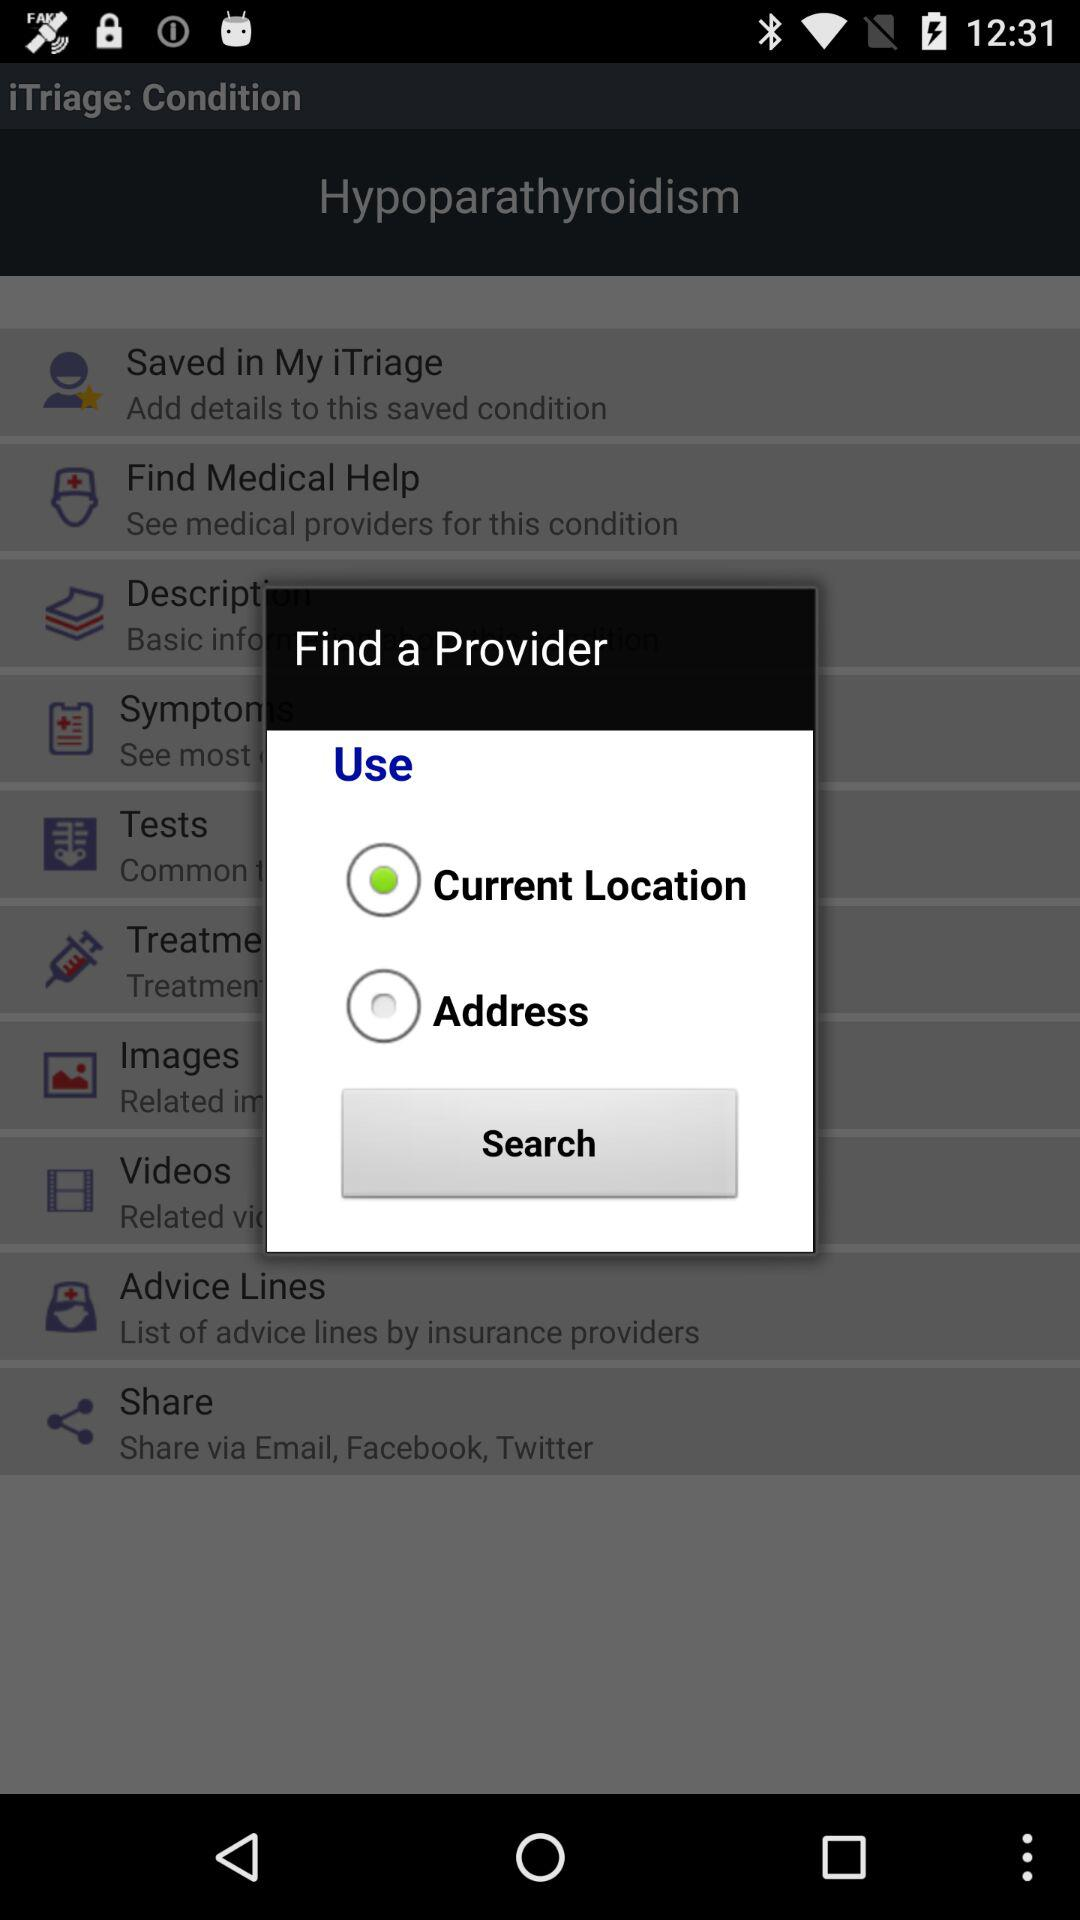What is the name of the application? The name of the application is "iTriage". 